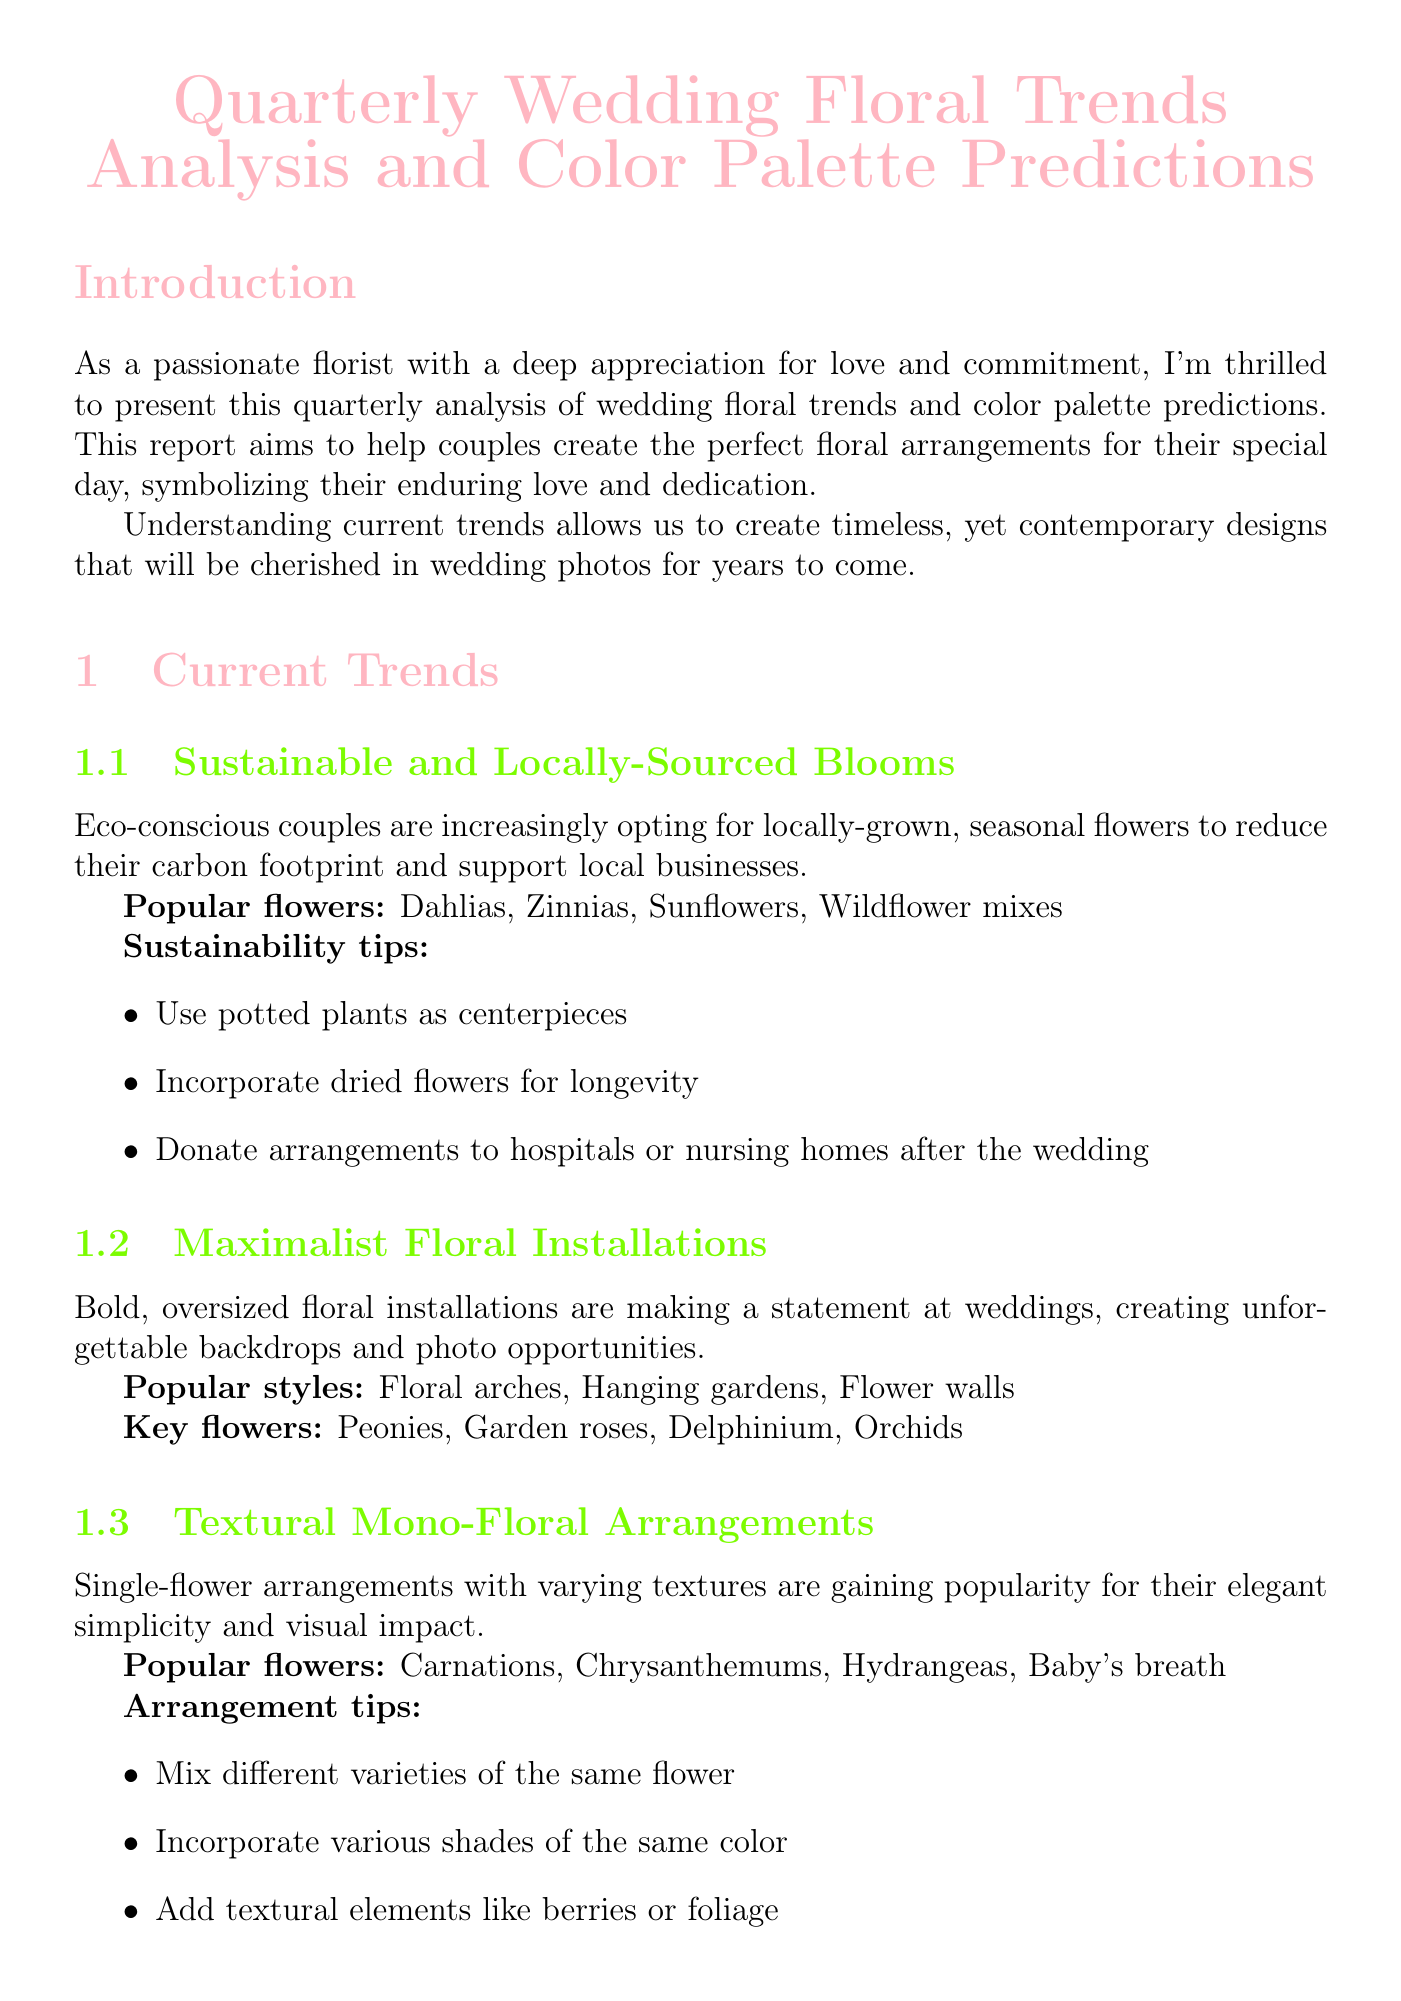What is the title of the report? The title of the report is stated at the beginning of the document.
Answer: Quarterly Wedding Floral Trends Analysis and Color Palette Predictions What trend promotes eco-consciousness? The specific trend highlighting eco-conscious practices is mentioned in the current trends section.
Answer: Sustainable and Locally-Sourced Blooms Which flowers are popular in the 'Frosted Elegance' palette? The popular flowers for the winter season color palette are listed under color palette predictions.
Answer: Anemones, Dusty Miller, White roses, Pine branches What is one sustainability tip mentioned? The report provides sustainability tips under the section about sustainable blooms.
Answer: Use potted plants as centerpieces How many color palettes are predicted in the report? The total number of color palettes for different seasons can be counted in the color palette predictions section.
Answer: Four What is the emerging trend related to vintage charm? The document discusses a trend that emphasizes the vintage aesthetic and sustainability, found in the emerging trends section.
Answer: Dried Flower Resurgence Which color is included in the 'Vibrant Sunset' palette? A specific color is identified in the color palette predictions for summer.
Answer: Coral What type of arrangements are gaining popularity due to their simplicity? This arrangement style is highlighted in the current trends, focusing on a specific approach to flower arrangement.
Answer: Textural Mono-Floral Arrangements 